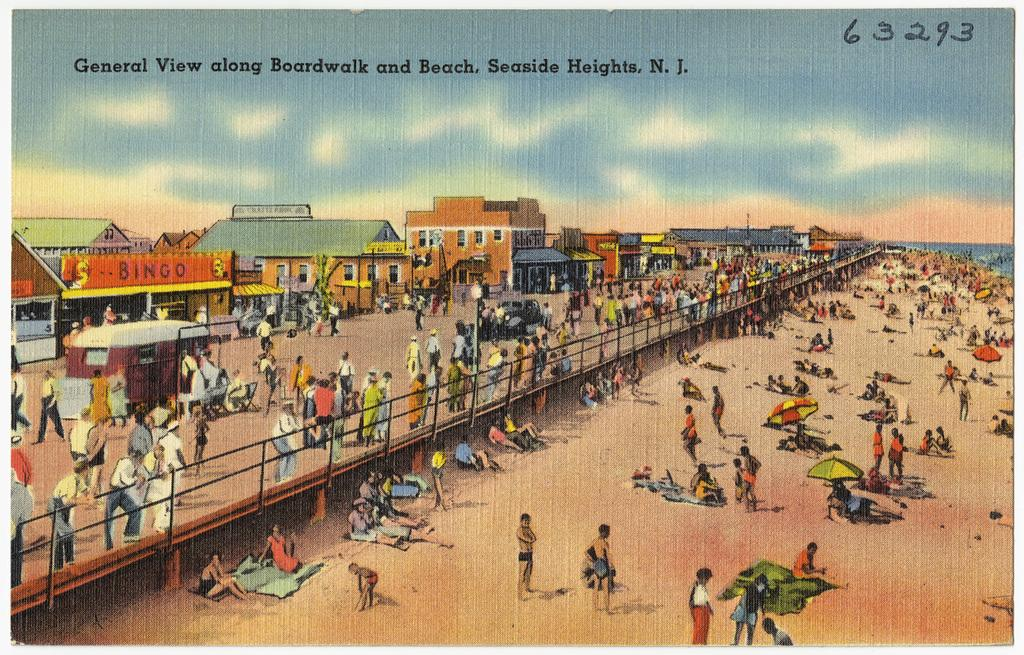<image>
Relay a brief, clear account of the picture shown. A postcard with a beach scene from New Jersey. 